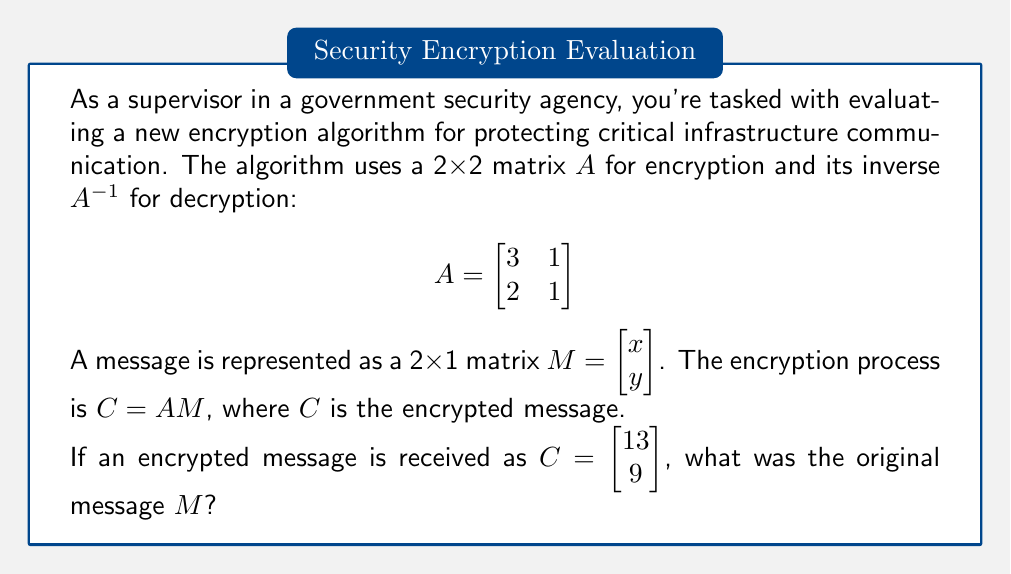Show me your answer to this math problem. To solve this problem, we need to follow these steps:

1) First, we need to find the inverse of matrix $A$. The formula for the inverse of a 2x2 matrix $\begin{bmatrix} a & b \\ c & d \end{bmatrix}$ is:

   $$A^{-1} = \frac{1}{ad-bc} \begin{bmatrix} d & -b \\ -c & a \end{bmatrix}$$

2) For our matrix $A$:
   
   $$A^{-1} = \frac{1}{3(1)-1(2)} \begin{bmatrix} 1 & -1 \\ -2 & 3 \end{bmatrix} = \begin{bmatrix} 1 & -1 \\ -2 & 3 \end{bmatrix}$$

3) Now, we can use the decryption formula: $M = A^{-1}C$

4) Let's multiply:

   $$\begin{bmatrix} 1 & -1 \\ -2 & 3 \end{bmatrix} \begin{bmatrix} 13 \\ 9 \end{bmatrix} = \begin{bmatrix} 1(13) + (-1)(9) \\ (-2)(13) + 3(9) \end{bmatrix}$$

5) Calculating:

   $$M = \begin{bmatrix} 13 - 9 \\ -26 + 27 \end{bmatrix} = \begin{bmatrix} 4 \\ 1 \end{bmatrix}$$

Therefore, the original message was $M = \begin{bmatrix} 4 \\ 1 \end{bmatrix}$.
Answer: $\begin{bmatrix} 4 \\ 1 \end{bmatrix}$ 